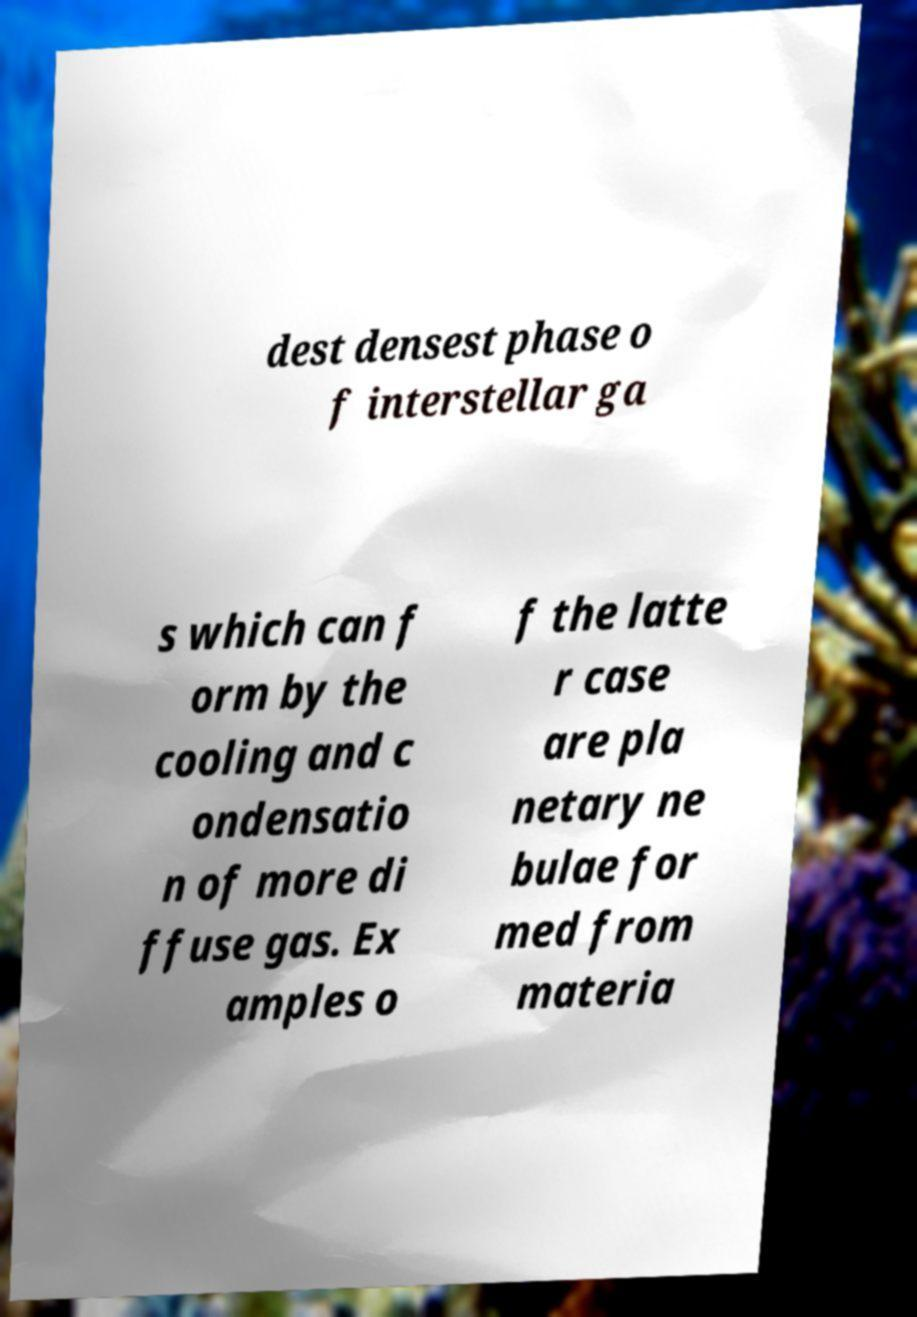For documentation purposes, I need the text within this image transcribed. Could you provide that? dest densest phase o f interstellar ga s which can f orm by the cooling and c ondensatio n of more di ffuse gas. Ex amples o f the latte r case are pla netary ne bulae for med from materia 